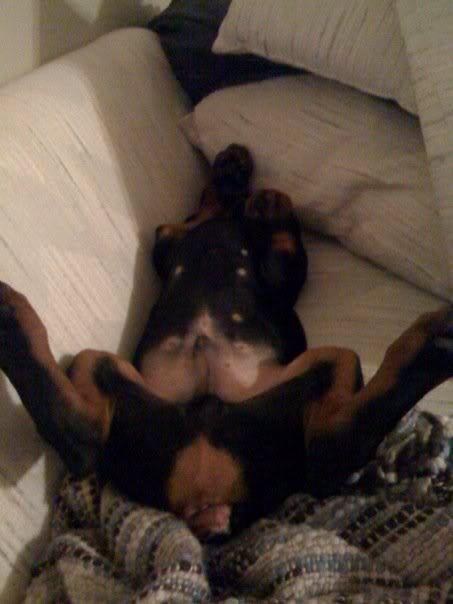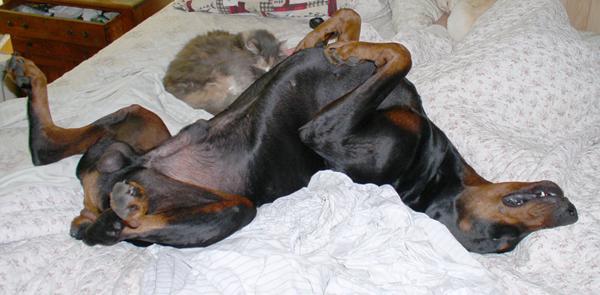The first image is the image on the left, the second image is the image on the right. Considering the images on both sides, is "Both images show a dog sleeping on their back exposing their belly." valid? Answer yes or no. Yes. The first image is the image on the left, the second image is the image on the right. Considering the images on both sides, is "All dogs shown are sleeping on their backs with their front paws bent, and the dog on the right has its head flung back and its muzzle at the lower right." valid? Answer yes or no. Yes. 